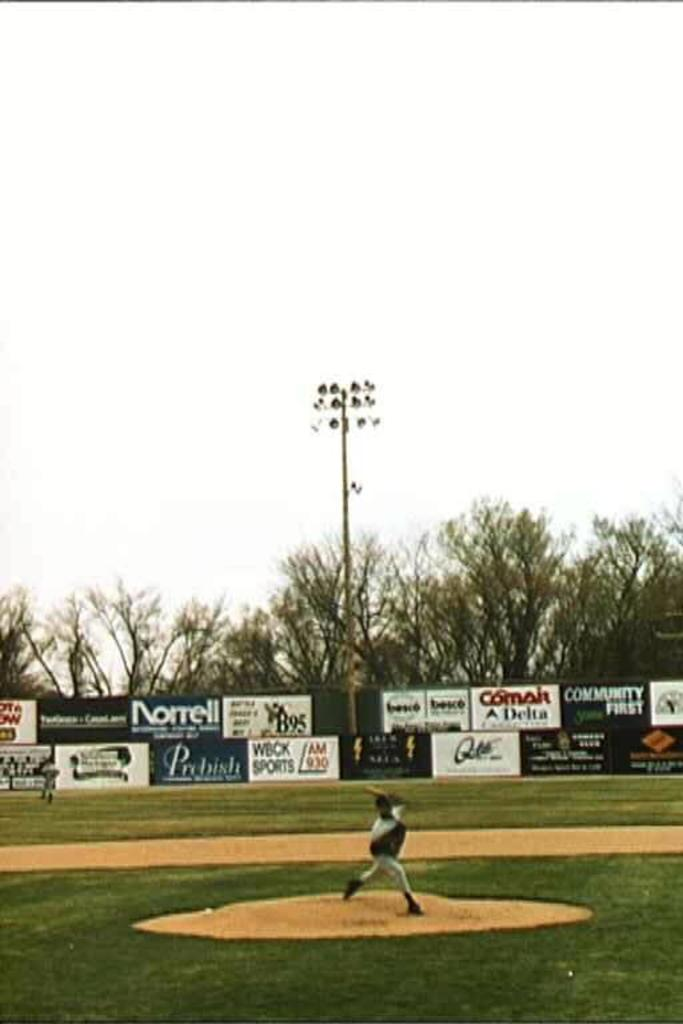What is happening on the ground in the image? There are players on the ground in the image. What can be seen in the background of the image? There are advertisements, lights, trees, and the sky visible in the background of the image. What type of animal is using the rake in the image? There is no animal or rake present in the image. What color is the powder that is sprinkled on the players in the image? There is no powder present in the image; the players are not covered in any substance. 